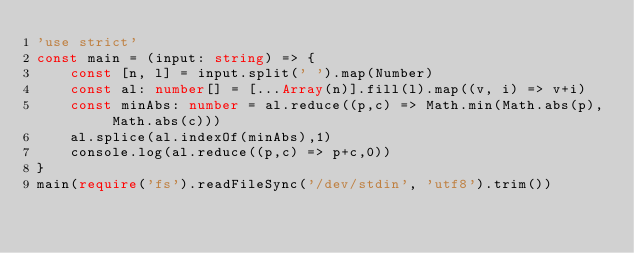<code> <loc_0><loc_0><loc_500><loc_500><_TypeScript_>'use strict'
const main = (input: string) => {
    const [n, l] = input.split(' ').map(Number)
    const al: number[] = [...Array(n)].fill(l).map((v, i) => v+i)
    const minAbs: number = al.reduce((p,c) => Math.min(Math.abs(p), Math.abs(c)))
    al.splice(al.indexOf(minAbs),1)
    console.log(al.reduce((p,c) => p+c,0))
}
main(require('fs').readFileSync('/dev/stdin', 'utf8').trim())</code> 